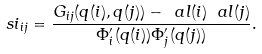<formula> <loc_0><loc_0><loc_500><loc_500>\ s i _ { i j } = \frac { G _ { i j } ( q ( i ) , q ( j ) ) - \ a l ( i ) \ a l ( j ) } { \Phi _ { i } ^ { \prime } ( q ( i ) ) \Phi _ { j } ^ { \prime } ( q ( j ) ) } .</formula> 